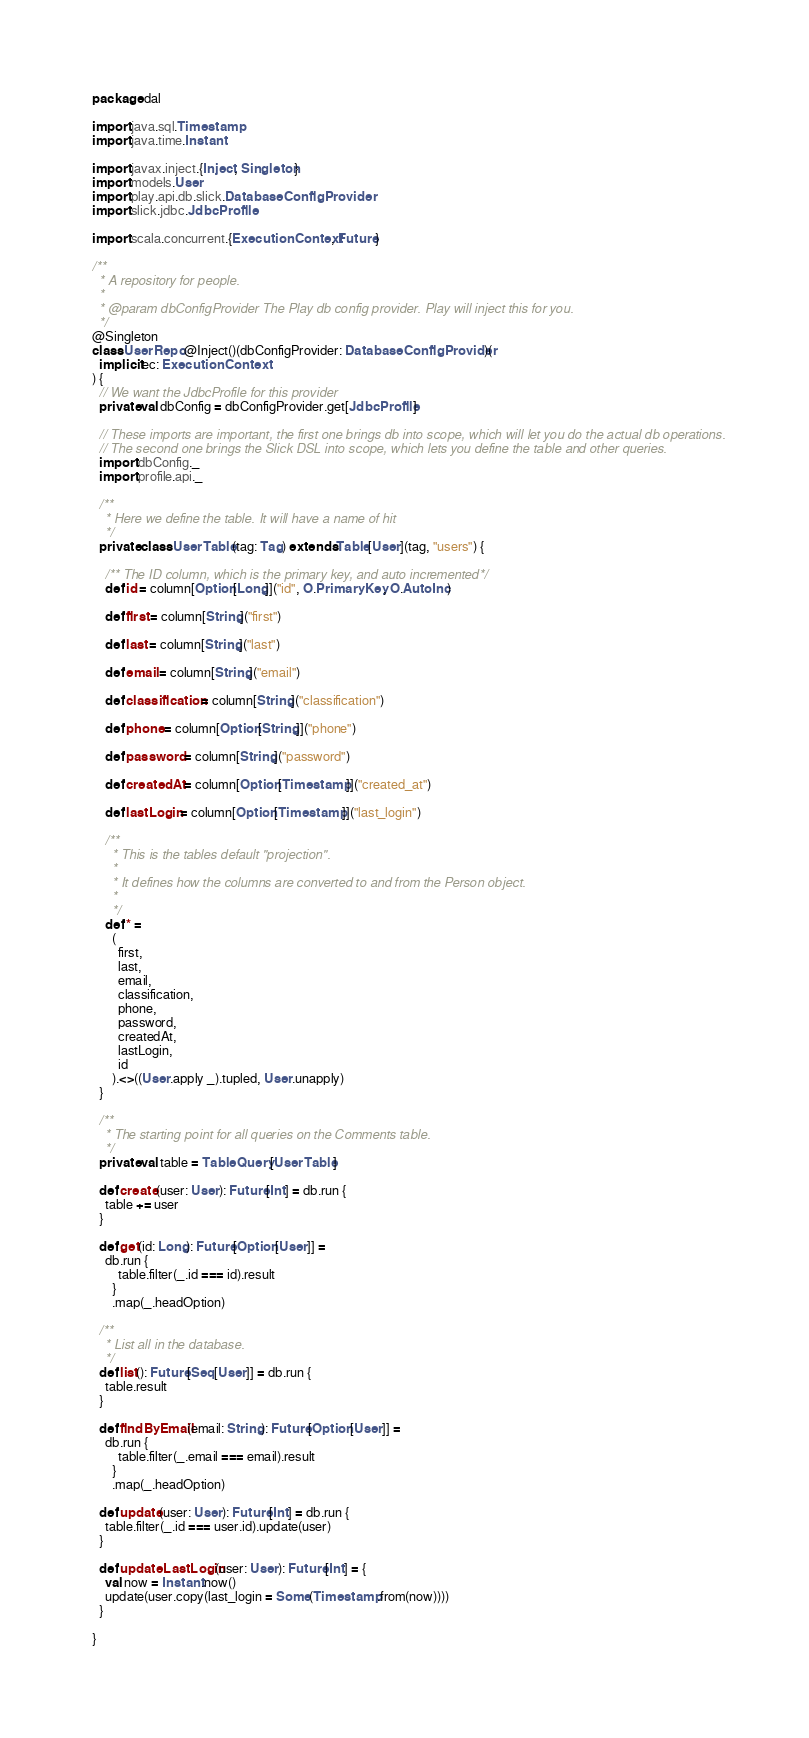<code> <loc_0><loc_0><loc_500><loc_500><_Scala_>package dal

import java.sql.Timestamp
import java.time.Instant

import javax.inject.{Inject, Singleton}
import models.User
import play.api.db.slick.DatabaseConfigProvider
import slick.jdbc.JdbcProfile

import scala.concurrent.{ExecutionContext, Future}

/**
  * A repository for people.
  *
  * @param dbConfigProvider The Play db config provider. Play will inject this for you.
  */
@Singleton
class UserRepo @Inject()(dbConfigProvider: DatabaseConfigProvider)(
  implicit ec: ExecutionContext
) {
  // We want the JdbcProfile for this provider
  private val dbConfig = dbConfigProvider.get[JdbcProfile]

  // These imports are important, the first one brings db into scope, which will let you do the actual db operations.
  // The second one brings the Slick DSL into scope, which lets you define the table and other queries.
  import dbConfig._
  import profile.api._

  /**
    * Here we define the table. It will have a name of hit
    */
  private class UserTable(tag: Tag) extends Table[User](tag, "users") {

    /** The ID column, which is the primary key, and auto incremented */
    def id = column[Option[Long]]("id", O.PrimaryKey, O.AutoInc)

    def first = column[String]("first")

    def last = column[String]("last")

    def email = column[String]("email")

    def classification = column[String]("classification")

    def phone = column[Option[String]]("phone")

    def password = column[String]("password")

    def createdAt = column[Option[Timestamp]]("created_at")

    def lastLogin = column[Option[Timestamp]]("last_login")

    /**
      * This is the tables default "projection".
      *
      * It defines how the columns are converted to and from the Person object.
      *
      */
    def * =
      (
        first,
        last,
        email,
        classification,
        phone,
        password,
        createdAt,
        lastLogin,
        id
      ).<>((User.apply _).tupled, User.unapply)
  }

  /**
    * The starting point for all queries on the Comments table.
    */
  private val table = TableQuery[UserTable]

  def create(user: User): Future[Int] = db.run {
    table += user
  }

  def get(id: Long): Future[Option[User]] =
    db.run {
        table.filter(_.id === id).result
      }
      .map(_.headOption)

  /**
    * List all in the database.
    */
  def list(): Future[Seq[User]] = db.run {
    table.result
  }

  def findByEmail(email: String): Future[Option[User]] =
    db.run {
        table.filter(_.email === email).result
      }
      .map(_.headOption)

  def update(user: User): Future[Int] = db.run {
    table.filter(_.id === user.id).update(user)
  }

  def updateLastLogin(user: User): Future[Int] = {
    val now = Instant.now()
    update(user.copy(last_login = Some(Timestamp.from(now))))
  }

}
</code> 